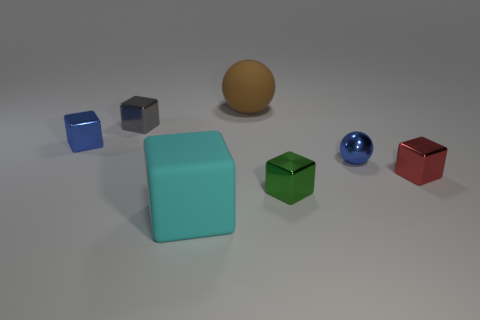Are there the same number of small blocks behind the brown matte ball and small spheres that are in front of the red shiny cube?
Provide a succinct answer. Yes. Do the red block and the green thing have the same material?
Keep it short and to the point. Yes. What number of green things are either large cubes or balls?
Your answer should be compact. 0. What number of other brown matte objects are the same shape as the large brown object?
Keep it short and to the point. 0. What is the material of the small gray thing?
Ensure brevity in your answer.  Metal. Are there an equal number of matte balls in front of the large cyan matte cube and green metal objects?
Make the answer very short. No. There is a green thing that is the same size as the gray object; what is its shape?
Offer a very short reply. Cube. Are there any cyan matte things left of the matte object that is in front of the red shiny object?
Provide a short and direct response. No. How many tiny things are gray metallic cubes or blue shiny objects?
Ensure brevity in your answer.  3. Is there a purple thing that has the same size as the blue metallic block?
Your answer should be compact. No. 